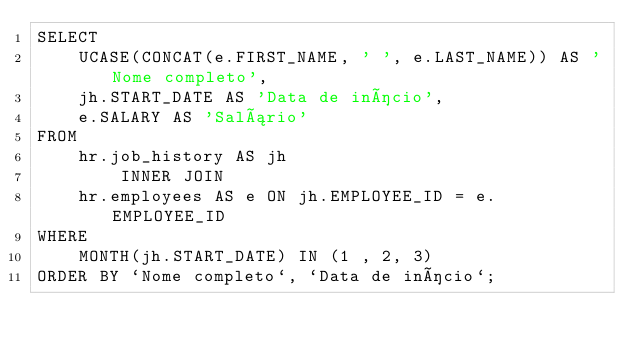Convert code to text. <code><loc_0><loc_0><loc_500><loc_500><_SQL_>SELECT 
    UCASE(CONCAT(e.FIRST_NAME, ' ', e.LAST_NAME)) AS 'Nome completo',
    jh.START_DATE AS 'Data de início',
    e.SALARY AS 'Salário'
FROM
    hr.job_history AS jh
        INNER JOIN
    hr.employees AS e ON jh.EMPLOYEE_ID = e.EMPLOYEE_ID
WHERE
    MONTH(jh.START_DATE) IN (1 , 2, 3)
ORDER BY `Nome completo`, `Data de início`;
</code> 